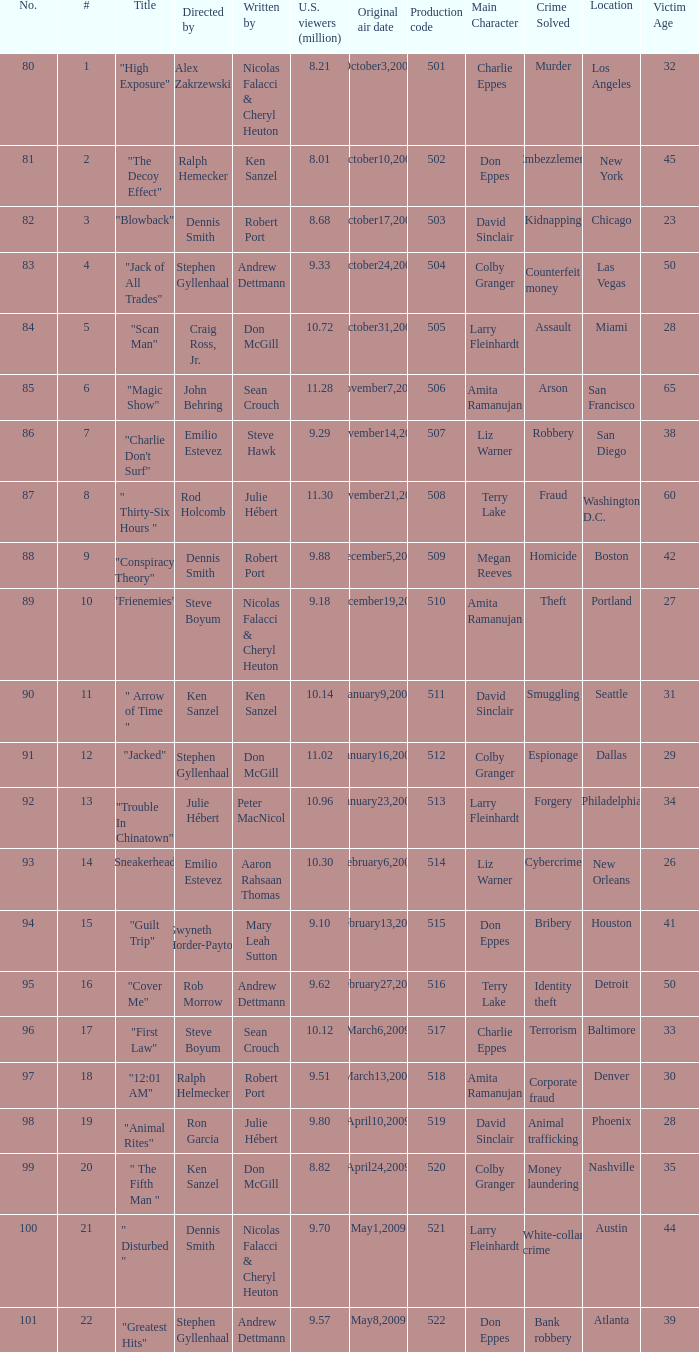What episode number was directed by Craig Ross, Jr. 5.0. 